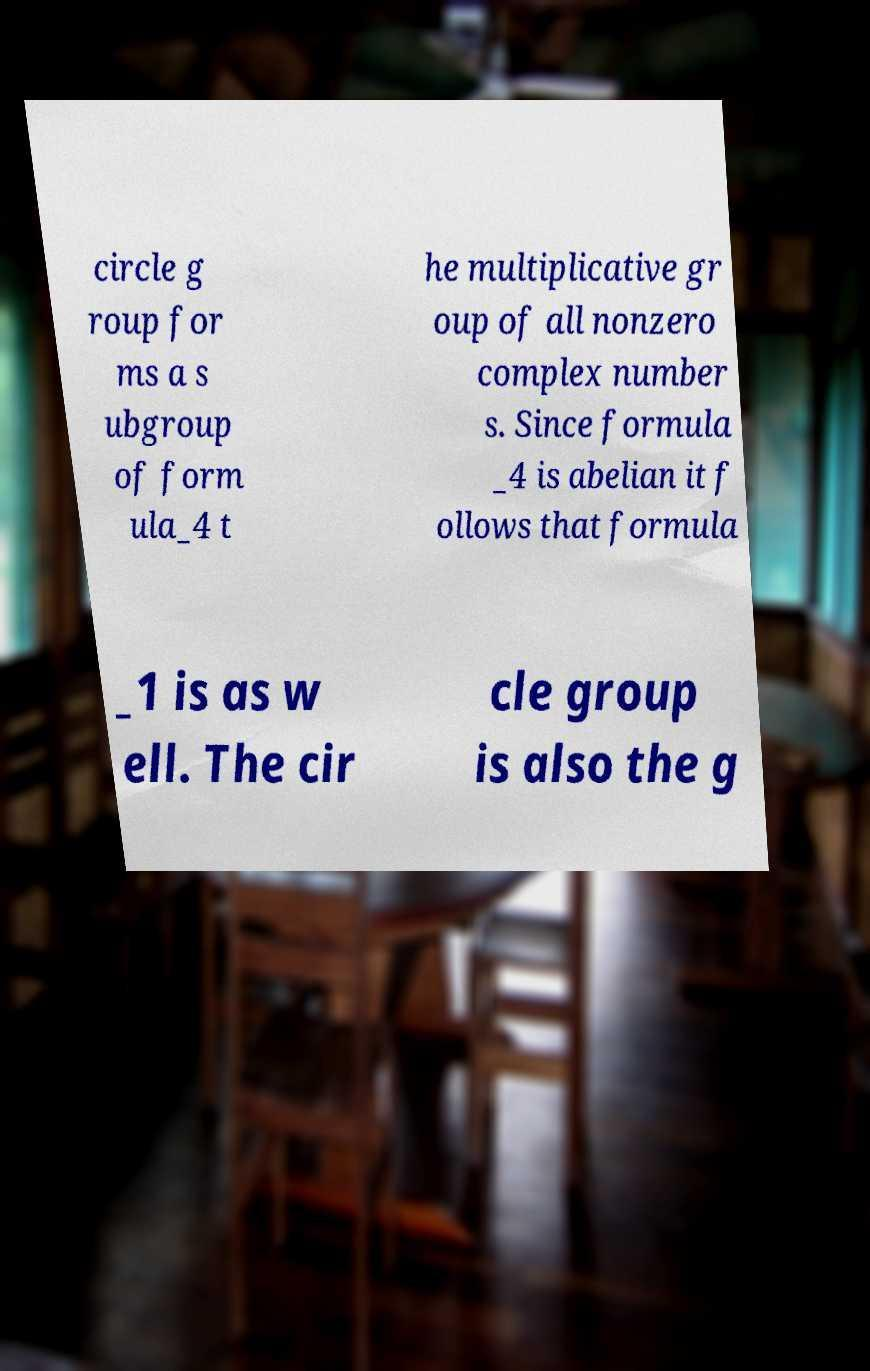Could you assist in decoding the text presented in this image and type it out clearly? circle g roup for ms a s ubgroup of form ula_4 t he multiplicative gr oup of all nonzero complex number s. Since formula _4 is abelian it f ollows that formula _1 is as w ell. The cir cle group is also the g 